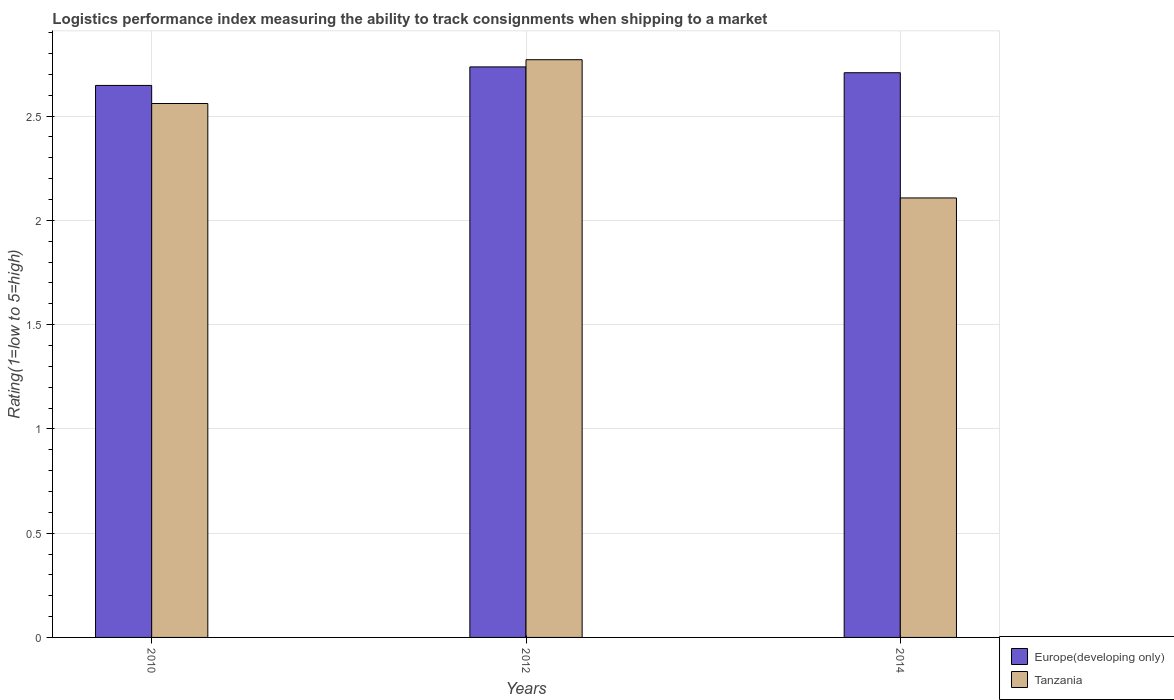How many bars are there on the 2nd tick from the left?
Offer a terse response. 2. How many bars are there on the 3rd tick from the right?
Ensure brevity in your answer.  2. What is the Logistic performance index in Europe(developing only) in 2014?
Provide a succinct answer. 2.71. Across all years, what is the maximum Logistic performance index in Europe(developing only)?
Give a very brief answer. 2.74. Across all years, what is the minimum Logistic performance index in Europe(developing only)?
Offer a terse response. 2.65. What is the total Logistic performance index in Europe(developing only) in the graph?
Provide a succinct answer. 8.09. What is the difference between the Logistic performance index in Europe(developing only) in 2012 and that in 2014?
Offer a terse response. 0.03. What is the difference between the Logistic performance index in Europe(developing only) in 2010 and the Logistic performance index in Tanzania in 2012?
Offer a very short reply. -0.12. What is the average Logistic performance index in Europe(developing only) per year?
Offer a terse response. 2.7. In the year 2012, what is the difference between the Logistic performance index in Europe(developing only) and Logistic performance index in Tanzania?
Offer a terse response. -0.03. What is the ratio of the Logistic performance index in Europe(developing only) in 2010 to that in 2012?
Offer a terse response. 0.97. What is the difference between the highest and the second highest Logistic performance index in Europe(developing only)?
Offer a terse response. 0.03. What is the difference between the highest and the lowest Logistic performance index in Europe(developing only)?
Make the answer very short. 0.09. In how many years, is the Logistic performance index in Tanzania greater than the average Logistic performance index in Tanzania taken over all years?
Make the answer very short. 2. Is the sum of the Logistic performance index in Tanzania in 2010 and 2012 greater than the maximum Logistic performance index in Europe(developing only) across all years?
Offer a terse response. Yes. What does the 1st bar from the left in 2012 represents?
Make the answer very short. Europe(developing only). What does the 1st bar from the right in 2012 represents?
Provide a short and direct response. Tanzania. What is the difference between two consecutive major ticks on the Y-axis?
Provide a short and direct response. 0.5. Does the graph contain grids?
Your answer should be very brief. Yes. Where does the legend appear in the graph?
Provide a succinct answer. Bottom right. How are the legend labels stacked?
Offer a very short reply. Vertical. What is the title of the graph?
Provide a short and direct response. Logistics performance index measuring the ability to track consignments when shipping to a market. What is the label or title of the X-axis?
Offer a very short reply. Years. What is the label or title of the Y-axis?
Your answer should be compact. Rating(1=low to 5=high). What is the Rating(1=low to 5=high) in Europe(developing only) in 2010?
Your answer should be compact. 2.65. What is the Rating(1=low to 5=high) in Tanzania in 2010?
Offer a terse response. 2.56. What is the Rating(1=low to 5=high) in Europe(developing only) in 2012?
Your answer should be compact. 2.74. What is the Rating(1=low to 5=high) in Tanzania in 2012?
Your answer should be compact. 2.77. What is the Rating(1=low to 5=high) of Europe(developing only) in 2014?
Provide a short and direct response. 2.71. What is the Rating(1=low to 5=high) in Tanzania in 2014?
Give a very brief answer. 2.11. Across all years, what is the maximum Rating(1=low to 5=high) in Europe(developing only)?
Provide a short and direct response. 2.74. Across all years, what is the maximum Rating(1=low to 5=high) in Tanzania?
Ensure brevity in your answer.  2.77. Across all years, what is the minimum Rating(1=low to 5=high) in Europe(developing only)?
Your answer should be very brief. 2.65. Across all years, what is the minimum Rating(1=low to 5=high) in Tanzania?
Provide a succinct answer. 2.11. What is the total Rating(1=low to 5=high) of Europe(developing only) in the graph?
Keep it short and to the point. 8.09. What is the total Rating(1=low to 5=high) in Tanzania in the graph?
Make the answer very short. 7.44. What is the difference between the Rating(1=low to 5=high) of Europe(developing only) in 2010 and that in 2012?
Your answer should be compact. -0.09. What is the difference between the Rating(1=low to 5=high) of Tanzania in 2010 and that in 2012?
Ensure brevity in your answer.  -0.21. What is the difference between the Rating(1=low to 5=high) in Europe(developing only) in 2010 and that in 2014?
Keep it short and to the point. -0.06. What is the difference between the Rating(1=low to 5=high) of Tanzania in 2010 and that in 2014?
Provide a succinct answer. 0.45. What is the difference between the Rating(1=low to 5=high) of Europe(developing only) in 2012 and that in 2014?
Keep it short and to the point. 0.03. What is the difference between the Rating(1=low to 5=high) in Tanzania in 2012 and that in 2014?
Offer a terse response. 0.66. What is the difference between the Rating(1=low to 5=high) in Europe(developing only) in 2010 and the Rating(1=low to 5=high) in Tanzania in 2012?
Give a very brief answer. -0.12. What is the difference between the Rating(1=low to 5=high) of Europe(developing only) in 2010 and the Rating(1=low to 5=high) of Tanzania in 2014?
Your response must be concise. 0.54. What is the difference between the Rating(1=low to 5=high) of Europe(developing only) in 2012 and the Rating(1=low to 5=high) of Tanzania in 2014?
Keep it short and to the point. 0.63. What is the average Rating(1=low to 5=high) of Europe(developing only) per year?
Give a very brief answer. 2.7. What is the average Rating(1=low to 5=high) of Tanzania per year?
Your answer should be very brief. 2.48. In the year 2010, what is the difference between the Rating(1=low to 5=high) of Europe(developing only) and Rating(1=low to 5=high) of Tanzania?
Offer a very short reply. 0.09. In the year 2012, what is the difference between the Rating(1=low to 5=high) in Europe(developing only) and Rating(1=low to 5=high) in Tanzania?
Offer a very short reply. -0.03. In the year 2014, what is the difference between the Rating(1=low to 5=high) of Europe(developing only) and Rating(1=low to 5=high) of Tanzania?
Make the answer very short. 0.6. What is the ratio of the Rating(1=low to 5=high) of Europe(developing only) in 2010 to that in 2012?
Give a very brief answer. 0.97. What is the ratio of the Rating(1=low to 5=high) of Tanzania in 2010 to that in 2012?
Make the answer very short. 0.92. What is the ratio of the Rating(1=low to 5=high) in Europe(developing only) in 2010 to that in 2014?
Your answer should be compact. 0.98. What is the ratio of the Rating(1=low to 5=high) of Tanzania in 2010 to that in 2014?
Your answer should be very brief. 1.21. What is the ratio of the Rating(1=low to 5=high) of Europe(developing only) in 2012 to that in 2014?
Give a very brief answer. 1.01. What is the ratio of the Rating(1=low to 5=high) of Tanzania in 2012 to that in 2014?
Provide a succinct answer. 1.31. What is the difference between the highest and the second highest Rating(1=low to 5=high) in Europe(developing only)?
Offer a very short reply. 0.03. What is the difference between the highest and the second highest Rating(1=low to 5=high) of Tanzania?
Provide a short and direct response. 0.21. What is the difference between the highest and the lowest Rating(1=low to 5=high) of Europe(developing only)?
Keep it short and to the point. 0.09. What is the difference between the highest and the lowest Rating(1=low to 5=high) in Tanzania?
Offer a terse response. 0.66. 